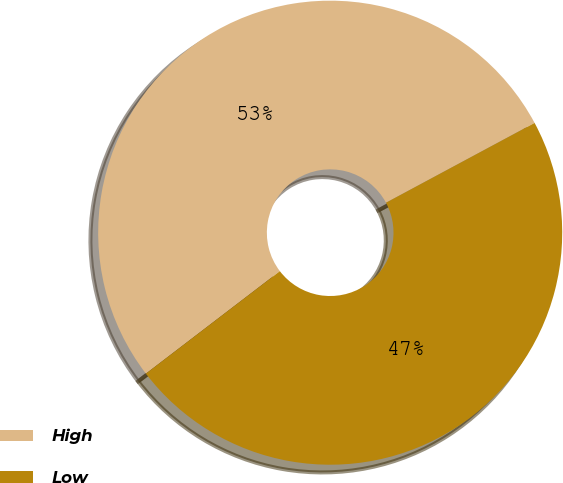Convert chart to OTSL. <chart><loc_0><loc_0><loc_500><loc_500><pie_chart><fcel>High<fcel>Low<nl><fcel>52.55%<fcel>47.45%<nl></chart> 